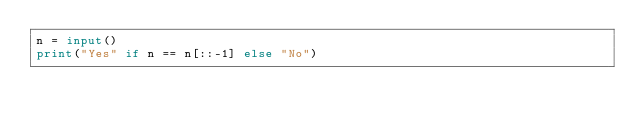Convert code to text. <code><loc_0><loc_0><loc_500><loc_500><_Python_>n = input()
print("Yes" if n == n[::-1] else "No")</code> 